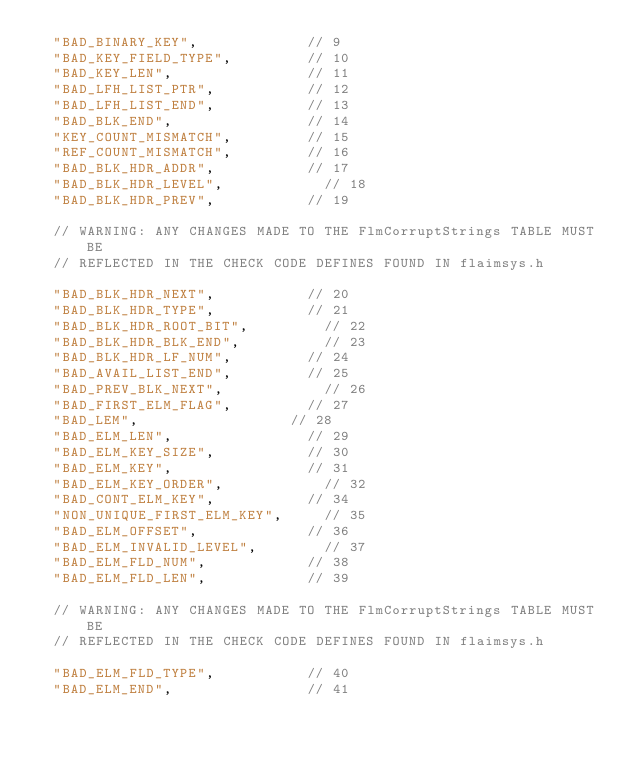Convert code to text. <code><loc_0><loc_0><loc_500><loc_500><_C++_>	"BAD_BINARY_KEY",							// 9
	"BAD_KEY_FIELD_TYPE",					// 10
	"BAD_KEY_LEN",								// 11
	"BAD_LFH_LIST_PTR",						// 12
	"BAD_LFH_LIST_END",						// 13
	"BAD_BLK_END",								// 14
	"KEY_COUNT_MISMATCH",					// 15
	"REF_COUNT_MISMATCH",					// 16
	"BAD_BLK_HDR_ADDR",						// 17
	"BAD_BLK_HDR_LEVEL",						// 18
	"BAD_BLK_HDR_PREV",						// 19

	// WARNING:	ANY CHANGES MADE TO THE FlmCorruptStrings TABLE MUST BE
	// REFLECTED IN THE CHECK CODE DEFINES FOUND IN flaimsys.h

	"BAD_BLK_HDR_NEXT",						// 20
	"BAD_BLK_HDR_TYPE",						// 21
	"BAD_BLK_HDR_ROOT_BIT",					// 22
	"BAD_BLK_HDR_BLK_END",					// 23
	"BAD_BLK_HDR_LF_NUM",					// 24
	"BAD_AVAIL_LIST_END",					// 25
	"BAD_PREV_BLK_NEXT",						// 26
	"BAD_FIRST_ELM_FLAG",					// 27
	"BAD_LEM",									// 28
	"BAD_ELM_LEN",								// 29
	"BAD_ELM_KEY_SIZE",						// 30
	"BAD_ELM_KEY",								// 31
	"BAD_ELM_KEY_ORDER",						// 32
	"BAD_CONT_ELM_KEY",						// 34
	"NON_UNIQUE_FIRST_ELM_KEY",			// 35
	"BAD_ELM_OFFSET",							// 36
	"BAD_ELM_INVALID_LEVEL",				// 37
	"BAD_ELM_FLD_NUM",						// 38
	"BAD_ELM_FLD_LEN",						// 39

	// WARNING:	ANY CHANGES MADE TO THE FlmCorruptStrings TABLE MUST BE
	// REFLECTED IN THE CHECK CODE DEFINES FOUND IN flaimsys.h

	"BAD_ELM_FLD_TYPE",						// 40
	"BAD_ELM_END",								// 41</code> 